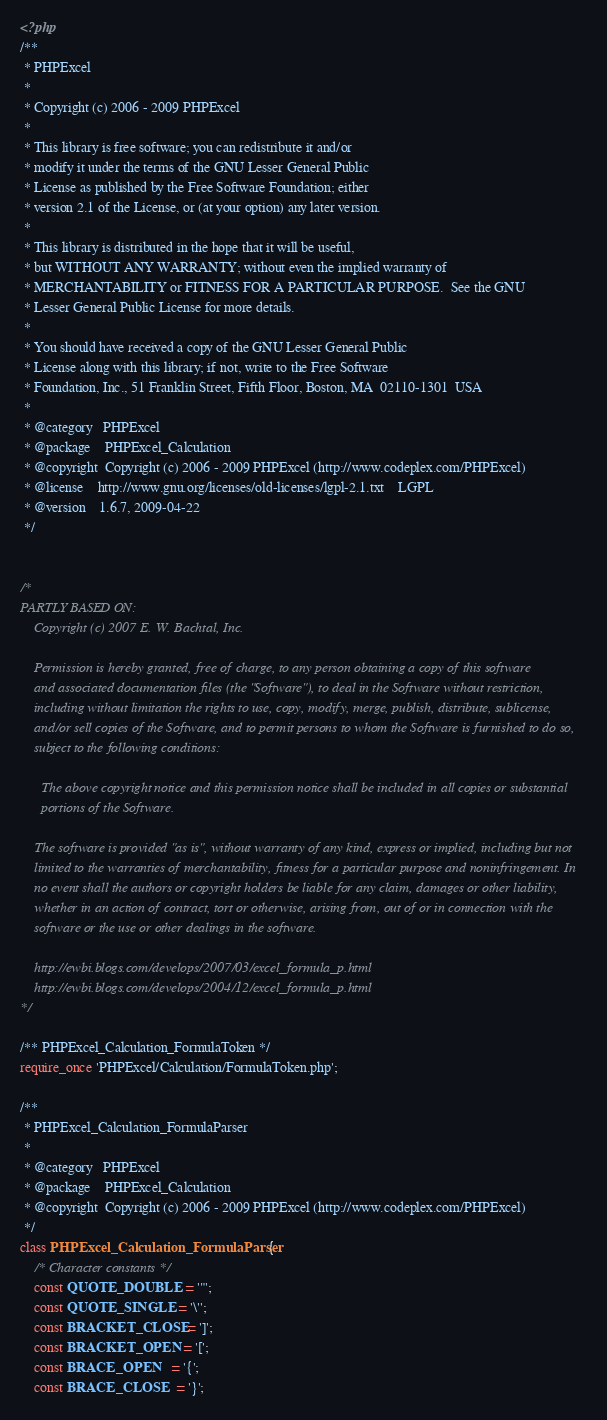<code> <loc_0><loc_0><loc_500><loc_500><_PHP_><?php
/**
 * PHPExcel
 *
 * Copyright (c) 2006 - 2009 PHPExcel
 *
 * This library is free software; you can redistribute it and/or
 * modify it under the terms of the GNU Lesser General Public
 * License as published by the Free Software Foundation; either
 * version 2.1 of the License, or (at your option) any later version.
 *
 * This library is distributed in the hope that it will be useful,
 * but WITHOUT ANY WARRANTY; without even the implied warranty of
 * MERCHANTABILITY or FITNESS FOR A PARTICULAR PURPOSE.  See the GNU
 * Lesser General Public License for more details.
 *
 * You should have received a copy of the GNU Lesser General Public
 * License along with this library; if not, write to the Free Software
 * Foundation, Inc., 51 Franklin Street, Fifth Floor, Boston, MA  02110-1301  USA
 *
 * @category   PHPExcel
 * @package    PHPExcel_Calculation
 * @copyright  Copyright (c) 2006 - 2009 PHPExcel (http://www.codeplex.com/PHPExcel)
 * @license    http://www.gnu.org/licenses/old-licenses/lgpl-2.1.txt	LGPL
 * @version    1.6.7, 2009-04-22
 */


/*
PARTLY BASED ON:
	Copyright (c) 2007 E. W. Bachtal, Inc.

	Permission is hereby granted, free of charge, to any person obtaining a copy of this software
	and associated documentation files (the "Software"), to deal in the Software without restriction,
	including without limitation the rights to use, copy, modify, merge, publish, distribute, sublicense,
	and/or sell copies of the Software, and to permit persons to whom the Software is furnished to do so,
	subject to the following conditions:

	  The above copyright notice and this permission notice shall be included in all copies or substantial
	  portions of the Software.

	The software is provided "as is", without warranty of any kind, express or implied, including but not
	limited to the warranties of merchantability, fitness for a particular purpose and noninfringement. In
	no event shall the authors or copyright holders be liable for any claim, damages or other liability,
	whether in an action of contract, tort or otherwise, arising from, out of or in connection with the
	software or the use or other dealings in the software.

	http://ewbi.blogs.com/develops/2007/03/excel_formula_p.html
	http://ewbi.blogs.com/develops/2004/12/excel_formula_p.html
*/

/** PHPExcel_Calculation_FormulaToken */
require_once 'PHPExcel/Calculation/FormulaToken.php';

/**
 * PHPExcel_Calculation_FormulaParser
 *
 * @category   PHPExcel
 * @package    PHPExcel_Calculation
 * @copyright  Copyright (c) 2006 - 2009 PHPExcel (http://www.codeplex.com/PHPExcel)
 */
class PHPExcel_Calculation_FormulaParser {
	/* Character constants */
	const QUOTE_DOUBLE  = '"';
	const QUOTE_SINGLE  = '\'';
	const BRACKET_CLOSE = ']';
	const BRACKET_OPEN  = '[';
	const BRACE_OPEN    = '{';
	const BRACE_CLOSE   = '}';</code> 